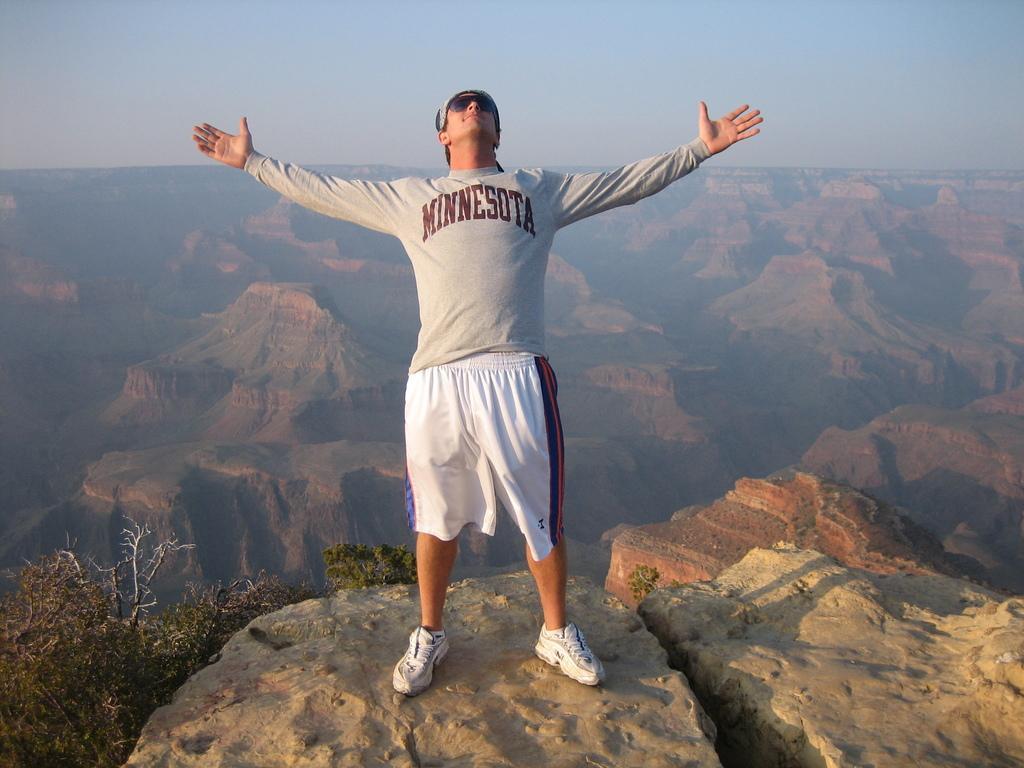In one or two sentences, can you explain what this image depicts? In this image we can see a man standing on the rock and there are some trees. We can see the mountains in the background and at the top we can see the sky. 